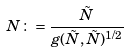<formula> <loc_0><loc_0><loc_500><loc_500>N \colon = \frac { \tilde { N } } { g ( \tilde { N } , \tilde { N } ) ^ { 1 / 2 } }</formula> 